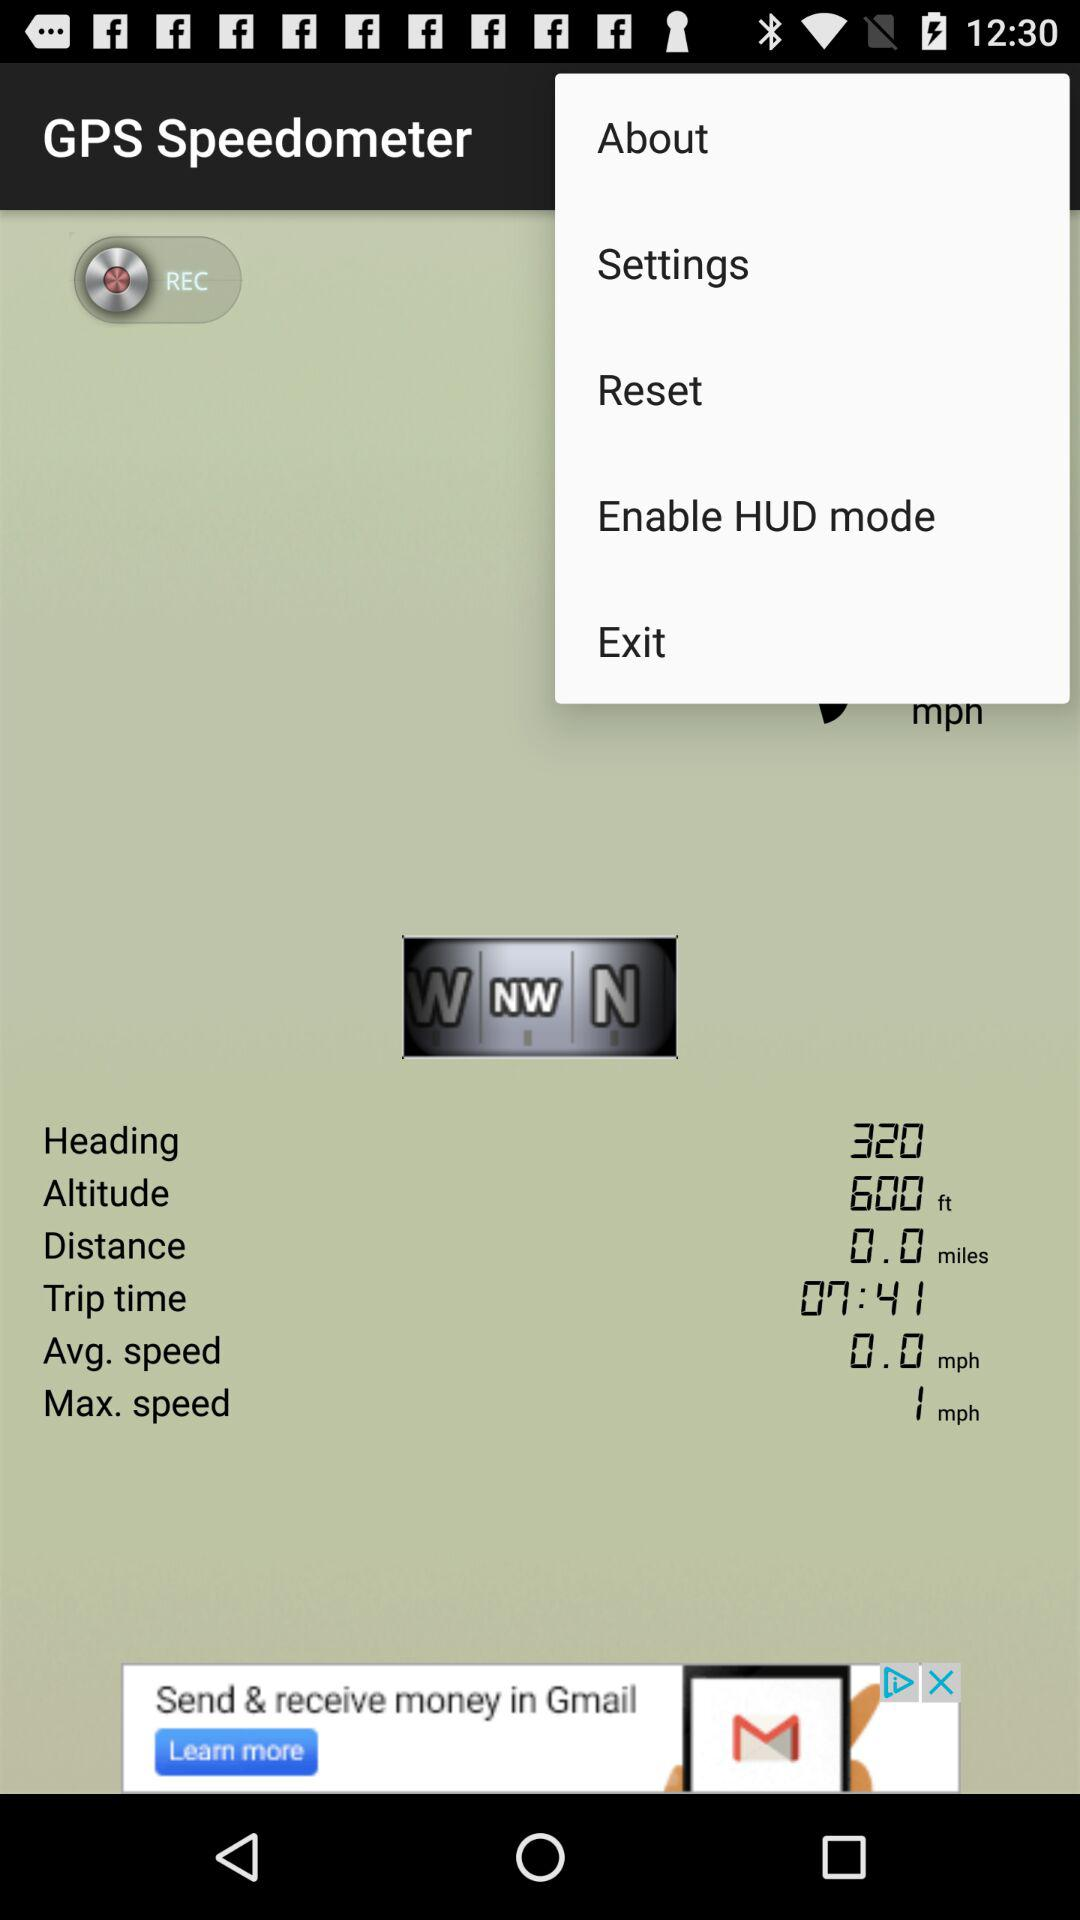What is the application name? The application name is "GPS Speedometer". 